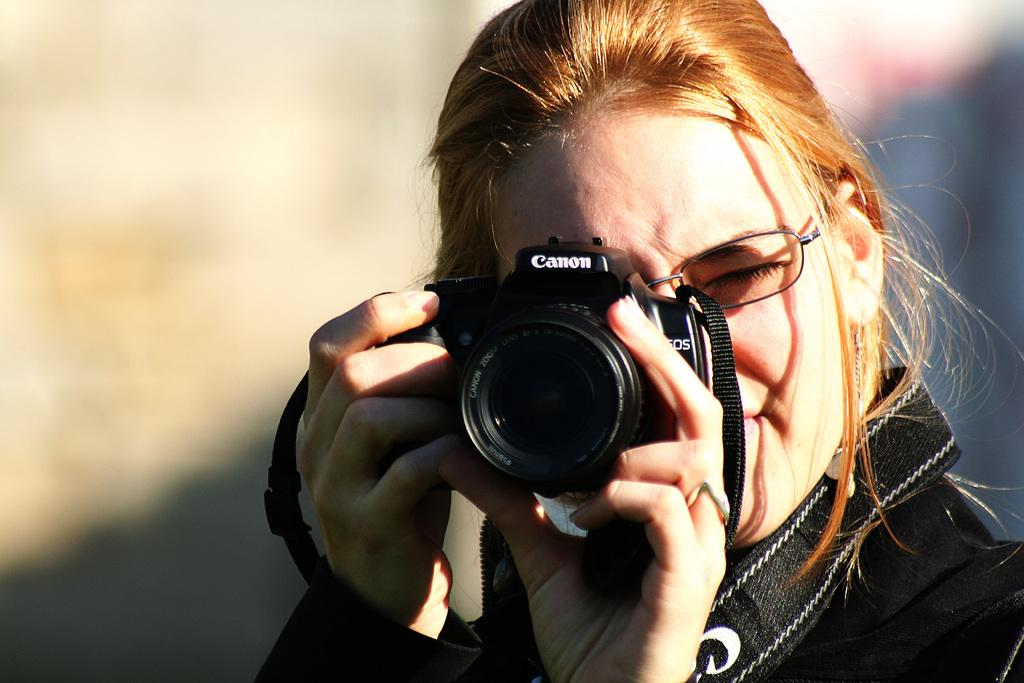What is present in the image? There is a person in the image. Can you describe the person's appearance? The person is wearing specs. What is the person holding in the image? The person is holding a camera. In which direction is the person swimming in the image? There is no indication of swimming in the image; the person is standing and holding a camera. 